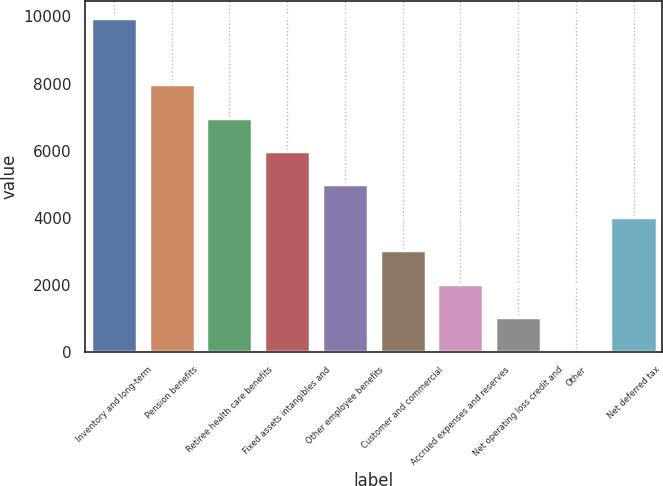Convert chart. <chart><loc_0><loc_0><loc_500><loc_500><bar_chart><fcel>Inventory and long-term<fcel>Pension benefits<fcel>Retiree health care benefits<fcel>Fixed assets intangibles and<fcel>Other employee benefits<fcel>Customer and commercial<fcel>Accrued expenses and reserves<fcel>Net operating loss credit and<fcel>Other<fcel>Net deferred tax<nl><fcel>9954<fcel>7974.6<fcel>6984.9<fcel>5995.2<fcel>5005.5<fcel>3026.1<fcel>2036.4<fcel>1046.7<fcel>57<fcel>4015.8<nl></chart> 